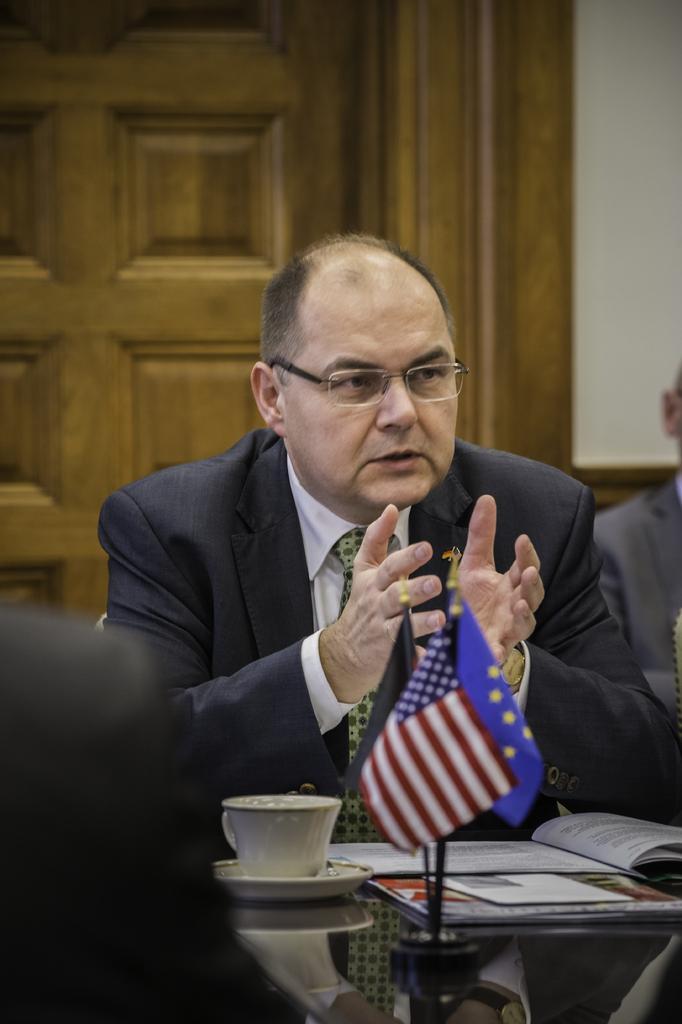In one or two sentences, can you explain what this image depicts? In this picture we can observe a person sitting in front of a table on which we can observe a cup and some papers are placed. This person is wearing a coat and spectacles. In the background we can observe a brown color door. 